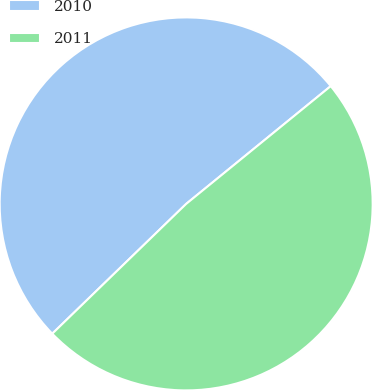Convert chart. <chart><loc_0><loc_0><loc_500><loc_500><pie_chart><fcel>2010<fcel>2011<nl><fcel>51.37%<fcel>48.63%<nl></chart> 